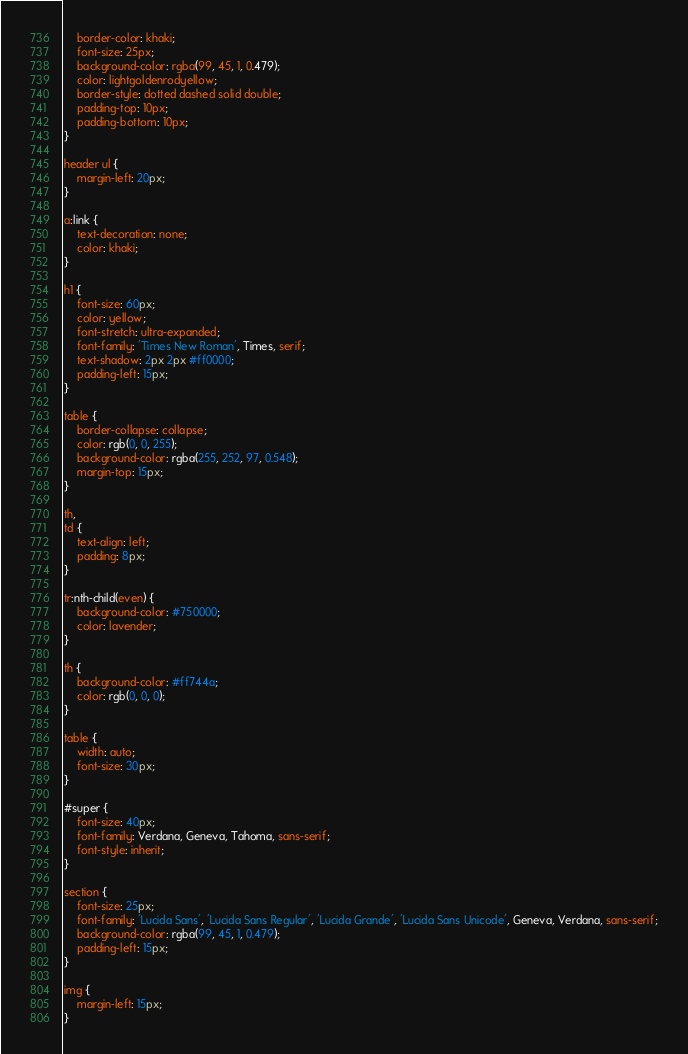<code> <loc_0><loc_0><loc_500><loc_500><_CSS_>    border-color: khaki;
    font-size: 25px;
    background-color: rgba(99, 45, 1, 0.479);
    color: lightgoldenrodyellow;
    border-style: dotted dashed solid double;
    padding-top: 10px;
    padding-bottom: 10px;
}

header ul {
    margin-left: 20px;
}

a:link {
    text-decoration: none;
    color: khaki;
}

h1 {
    font-size: 60px;
    color: yellow;
    font-stretch: ultra-expanded;
    font-family: 'Times New Roman', Times, serif;
    text-shadow: 2px 2px #ff0000;
    padding-left: 15px;
}

table {
    border-collapse: collapse;
    color: rgb(0, 0, 255);
    background-color: rgba(255, 252, 97, 0.548);
    margin-top: 15px;
}

th,
td {
    text-align: left;
    padding: 8px;
}

tr:nth-child(even) {
    background-color: #750000;
    color: lavender;
}

th {
    background-color: #ff744a;
    color: rgb(0, 0, 0);
}

table {
    width: auto;
    font-size: 30px;
}

#super {
    font-size: 40px;
    font-family: Verdana, Geneva, Tahoma, sans-serif;
    font-style: inherit;
}

section {
    font-size: 25px;
    font-family: 'Lucida Sans', 'Lucida Sans Regular', 'Lucida Grande', 'Lucida Sans Unicode', Geneva, Verdana, sans-serif;
    background-color: rgba(99, 45, 1, 0.479);
    padding-left: 15px;
}

img {
    margin-left: 15px;
}</code> 